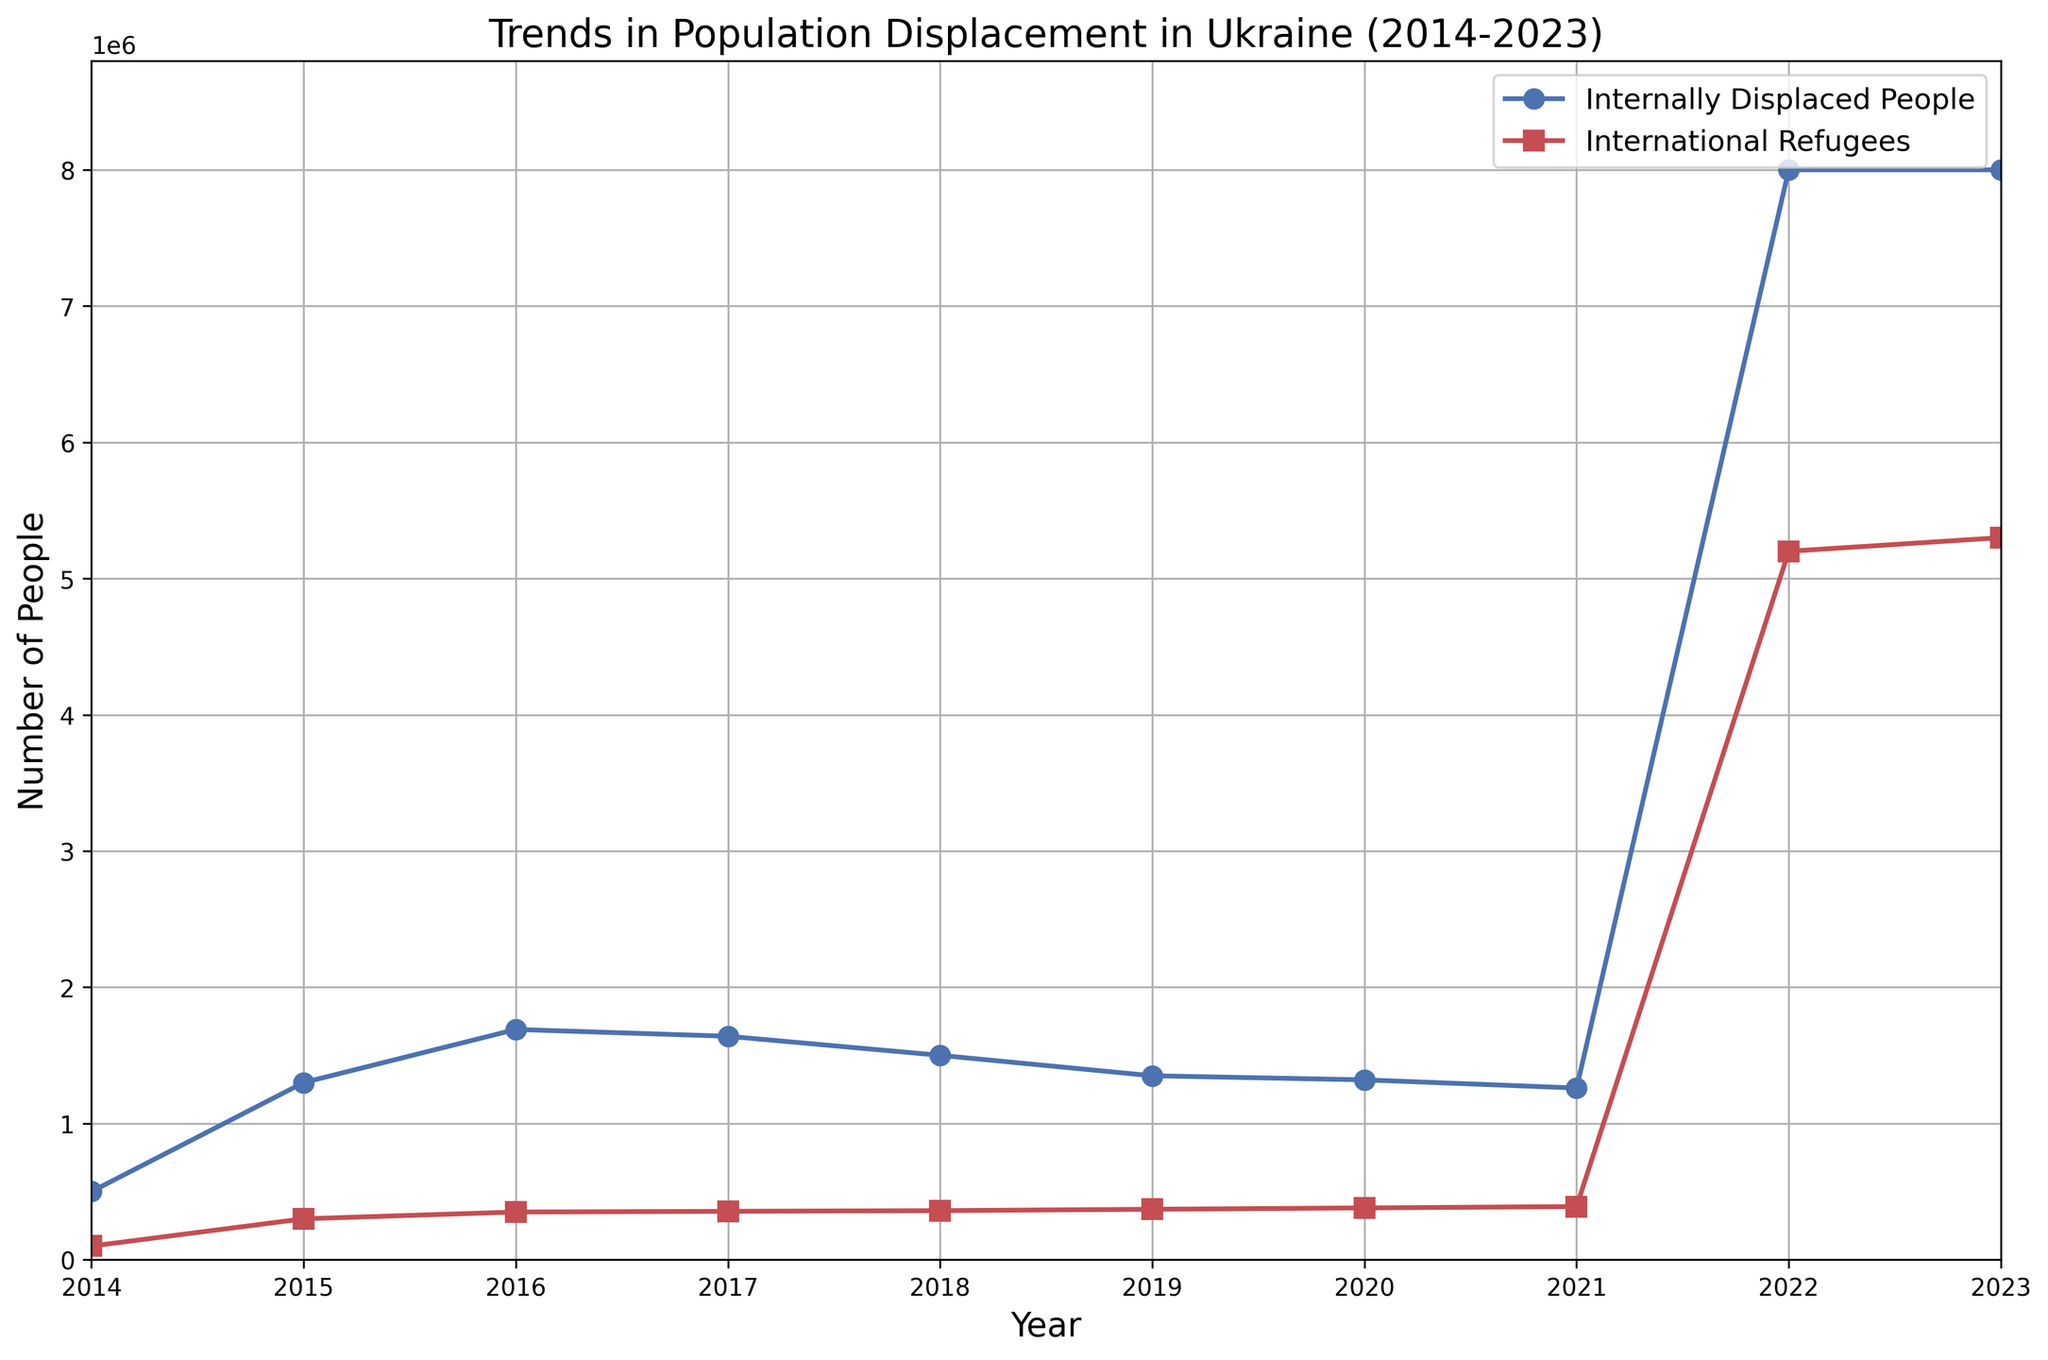Which year saw the highest number of Internally Displaced People? To determine the highest number of Internally Displaced People (IDP), we observe the blue line and look for the peak value. The peak occurs in 2022 and 2023 where the number is 8,000,000.
Answer: 2022 Which year saw the highest number of International Refugees? To determine the year with the highest number of International Refugees, observe the red line for the peak value. This occurs in 2023 where the number is 5,300,000.
Answer: 2023 Compare the trend of Internally Displaced People between 2014 and 2021. Did it increase or decrease? Observe the blue line from 2014 to 2021. It starts at 500,000 in 2014 and increases to a peak at around 1,690,000 in 2016, then steadily decreases to 1,260,000 by 2021.
Answer: Decrease By how much did the number of Internally Displaced People increase from 2021 to 2022? In 2021, the number of IDP was 1,260,000, and it increased to 8,000,000 in 2022. The increase is calculated as 8,000,000 - 1,260,000 = 6,740,000.
Answer: 6,740,000 Which category saw a higher absolute increase from 2021 to 2022, Internally Displaced People or International Refugees? For IDP, the increase from 2021 to 2022 is 6,740,000 (8,000,000 - 1,260,000). For International Refugees, the increase is 5,200,000 (5,200,000 - 390,000). Comparing these, IDP saw a higher increase.
Answer: Internally Displaced People What was the average number of International Refugees between 2014 and 2018? Sum of International Refugees from 2014 to 2018: 100,000 + 300,000 + 350,000 + 355,000 + 360,000 = 1,465,000. Average = 1,465,000 / 5 = 293,000.
Answer: 293,000 In which year did the number of Internally Displaced People stop increasing and start decreasing before the large rise in 2022? Observe the blue line. The number of IDP peaked in 2016 at 1,690,000, then began decreasing in 2017 at 1,640,000.
Answer: 2017 What is the ratio of Internally Displaced People to International Refugees in the year 2023? In 2023, the IDP number is 8,000,000, and the International Refugees number is 5,300,000. The ratio is calculated as 8,000,000 / 5,300,000 ≈ 1.51.
Answer: 1.51 How many more Internally Displaced People were there than International Refugees in 2022? In 2022, IDP was 8,000,000 and International Refugees were 5,200,000. The difference is 8,000,000 - 5,200,000 = 2,800,000.
Answer: 2,800,000 